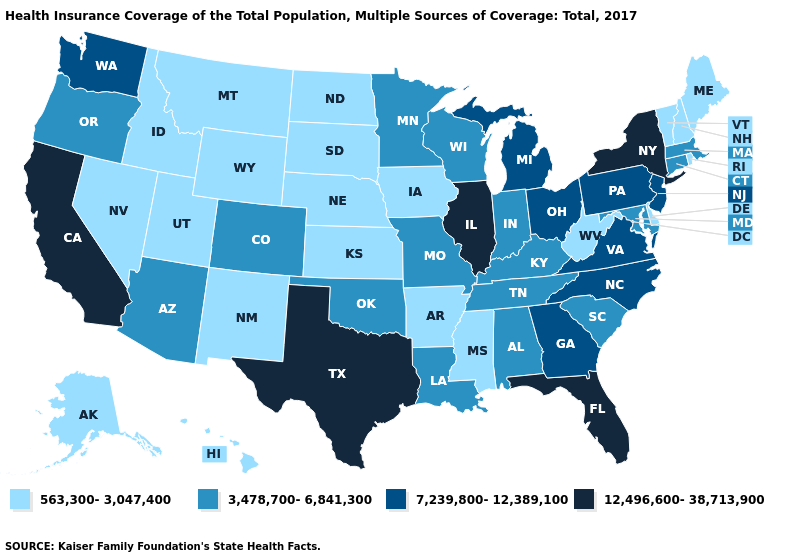What is the value of Oklahoma?
Answer briefly. 3,478,700-6,841,300. Name the states that have a value in the range 12,496,600-38,713,900?
Concise answer only. California, Florida, Illinois, New York, Texas. Name the states that have a value in the range 563,300-3,047,400?
Concise answer only. Alaska, Arkansas, Delaware, Hawaii, Idaho, Iowa, Kansas, Maine, Mississippi, Montana, Nebraska, Nevada, New Hampshire, New Mexico, North Dakota, Rhode Island, South Dakota, Utah, Vermont, West Virginia, Wyoming. What is the value of New Jersey?
Short answer required. 7,239,800-12,389,100. Does California have the highest value in the USA?
Be succinct. Yes. Which states have the lowest value in the USA?
Write a very short answer. Alaska, Arkansas, Delaware, Hawaii, Idaho, Iowa, Kansas, Maine, Mississippi, Montana, Nebraska, Nevada, New Hampshire, New Mexico, North Dakota, Rhode Island, South Dakota, Utah, Vermont, West Virginia, Wyoming. Does New Hampshire have the lowest value in the Northeast?
Keep it brief. Yes. Does the first symbol in the legend represent the smallest category?
Write a very short answer. Yes. Name the states that have a value in the range 12,496,600-38,713,900?
Write a very short answer. California, Florida, Illinois, New York, Texas. Does New York have the lowest value in the Northeast?
Short answer required. No. Does Oklahoma have the same value as Montana?
Write a very short answer. No. Does Nebraska have a lower value than Connecticut?
Concise answer only. Yes. What is the value of Missouri?
Answer briefly. 3,478,700-6,841,300. Name the states that have a value in the range 7,239,800-12,389,100?
Concise answer only. Georgia, Michigan, New Jersey, North Carolina, Ohio, Pennsylvania, Virginia, Washington. 